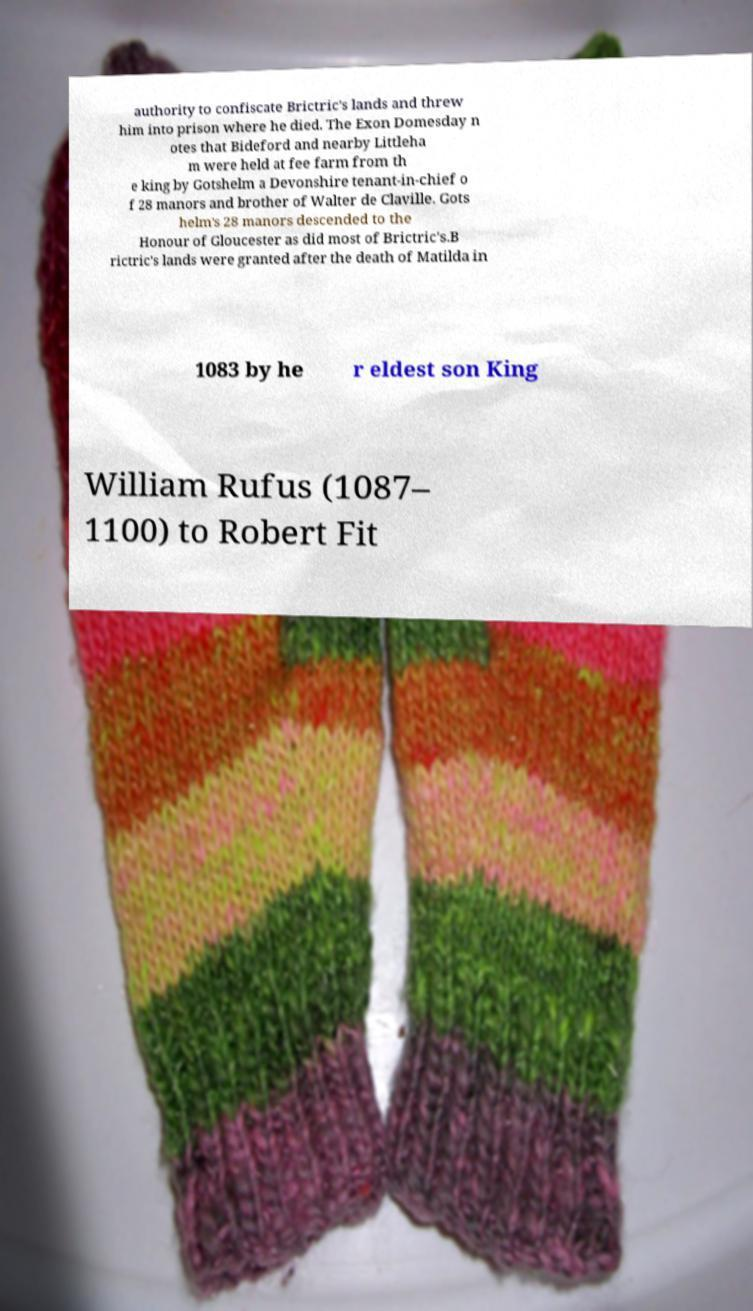There's text embedded in this image that I need extracted. Can you transcribe it verbatim? authority to confiscate Brictric's lands and threw him into prison where he died. The Exon Domesday n otes that Bideford and nearby Littleha m were held at fee farm from th e king by Gotshelm a Devonshire tenant-in-chief o f 28 manors and brother of Walter de Claville. Gots helm's 28 manors descended to the Honour of Gloucester as did most of Brictric's.B rictric's lands were granted after the death of Matilda in 1083 by he r eldest son King William Rufus (1087– 1100) to Robert Fit 